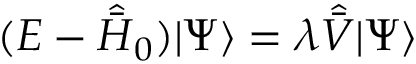<formula> <loc_0><loc_0><loc_500><loc_500>( E - \hat { \bar { H } } _ { 0 } ) | \Psi \rangle = \lambda \hat { \bar { V } } | \Psi \rangle</formula> 